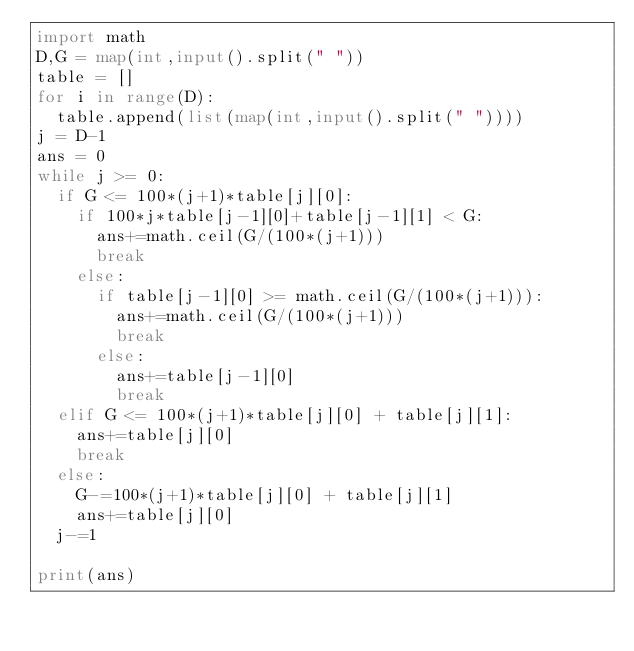<code> <loc_0><loc_0><loc_500><loc_500><_Python_>import math
D,G = map(int,input().split(" "))
table = []
for i in range(D):
  table.append(list(map(int,input().split(" "))))
j = D-1
ans = 0
while j >= 0:
  if G <= 100*(j+1)*table[j][0]:
    if 100*j*table[j-1][0]+table[j-1][1] < G: 
      ans+=math.ceil(G/(100*(j+1)))
      break
    else:
      if table[j-1][0] >= math.ceil(G/(100*(j+1))):
        ans+=math.ceil(G/(100*(j+1)))
        break 
      else:
        ans+=table[j-1][0]
        break
  elif G <= 100*(j+1)*table[j][0] + table[j][1]:
    ans+=table[j][0]
    break
  else:
    G-=100*(j+1)*table[j][0] + table[j][1]
    ans+=table[j][0]
  j-=1
    
print(ans)</code> 